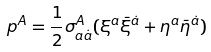Convert formula to latex. <formula><loc_0><loc_0><loc_500><loc_500>p ^ { A } = \frac { 1 } { 2 } \sigma _ { a \dot { a } } ^ { A } ( \xi ^ { a } \bar { \xi } ^ { \dot { a } } + \eta ^ { a } \bar { \eta } ^ { \dot { a } } )</formula> 